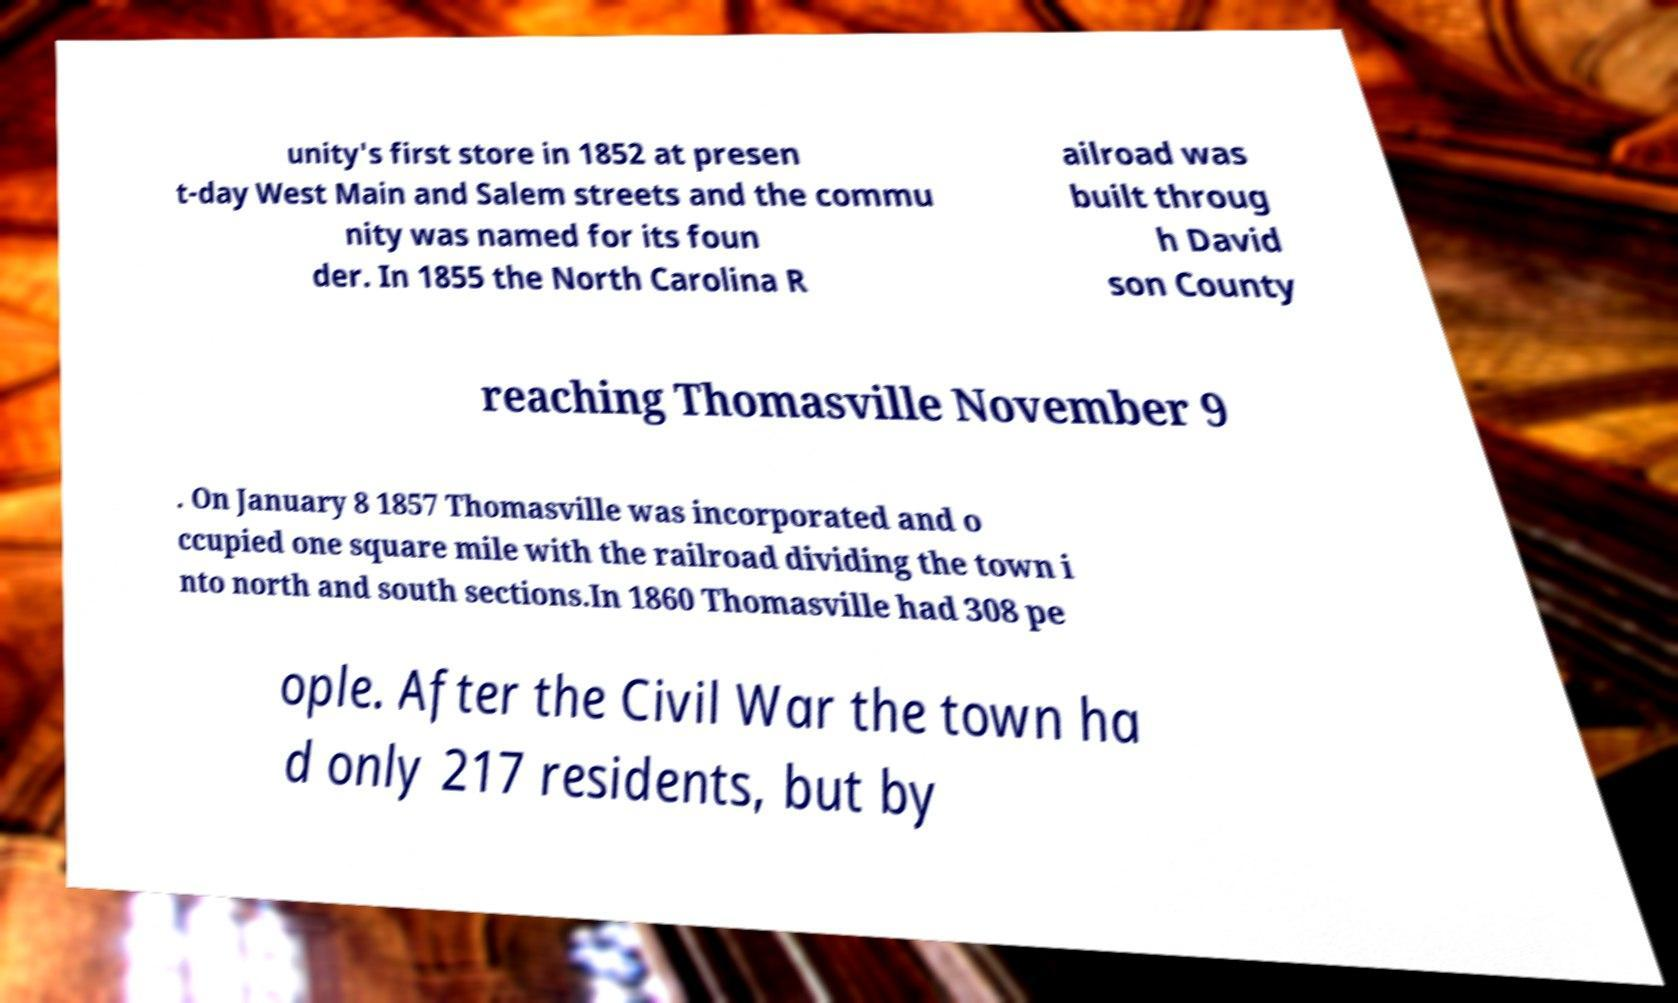Could you extract and type out the text from this image? unity's first store in 1852 at presen t-day West Main and Salem streets and the commu nity was named for its foun der. In 1855 the North Carolina R ailroad was built throug h David son County reaching Thomasville November 9 . On January 8 1857 Thomasville was incorporated and o ccupied one square mile with the railroad dividing the town i nto north and south sections.In 1860 Thomasville had 308 pe ople. After the Civil War the town ha d only 217 residents, but by 